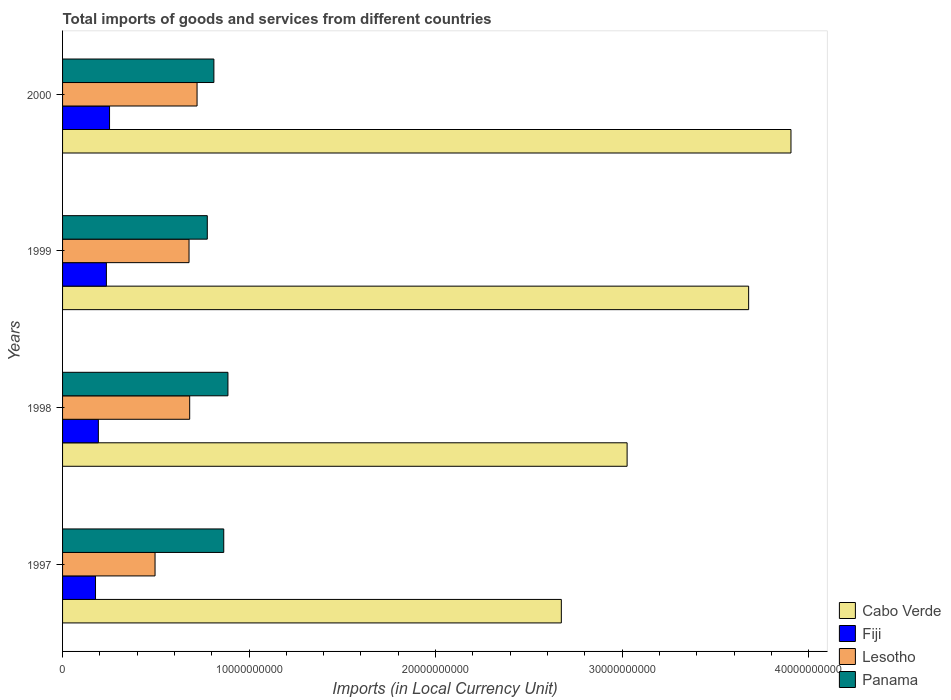How many different coloured bars are there?
Give a very brief answer. 4. Are the number of bars on each tick of the Y-axis equal?
Give a very brief answer. Yes. How many bars are there on the 1st tick from the top?
Make the answer very short. 4. How many bars are there on the 2nd tick from the bottom?
Ensure brevity in your answer.  4. What is the label of the 1st group of bars from the top?
Your answer should be very brief. 2000. What is the Amount of goods and services imports in Cabo Verde in 2000?
Provide a short and direct response. 3.91e+1. Across all years, what is the maximum Amount of goods and services imports in Cabo Verde?
Offer a terse response. 3.91e+1. Across all years, what is the minimum Amount of goods and services imports in Cabo Verde?
Offer a very short reply. 2.67e+1. In which year was the Amount of goods and services imports in Panama maximum?
Give a very brief answer. 1998. What is the total Amount of goods and services imports in Panama in the graph?
Your answer should be compact. 3.34e+1. What is the difference between the Amount of goods and services imports in Cabo Verde in 1998 and that in 1999?
Your answer should be compact. -6.52e+09. What is the difference between the Amount of goods and services imports in Fiji in 2000 and the Amount of goods and services imports in Cabo Verde in 1999?
Your answer should be compact. -3.43e+1. What is the average Amount of goods and services imports in Panama per year?
Provide a short and direct response. 8.35e+09. In the year 2000, what is the difference between the Amount of goods and services imports in Panama and Amount of goods and services imports in Lesotho?
Make the answer very short. 9.02e+08. In how many years, is the Amount of goods and services imports in Fiji greater than 20000000000 LCU?
Your answer should be very brief. 0. What is the ratio of the Amount of goods and services imports in Fiji in 1997 to that in 1998?
Keep it short and to the point. 0.92. Is the Amount of goods and services imports in Cabo Verde in 1997 less than that in 1998?
Your answer should be compact. Yes. What is the difference between the highest and the second highest Amount of goods and services imports in Panama?
Keep it short and to the point. 2.24e+08. What is the difference between the highest and the lowest Amount of goods and services imports in Fiji?
Make the answer very short. 7.52e+08. In how many years, is the Amount of goods and services imports in Panama greater than the average Amount of goods and services imports in Panama taken over all years?
Your answer should be very brief. 2. What does the 2nd bar from the top in 1998 represents?
Your answer should be compact. Lesotho. What does the 2nd bar from the bottom in 1999 represents?
Keep it short and to the point. Fiji. Is it the case that in every year, the sum of the Amount of goods and services imports in Lesotho and Amount of goods and services imports in Panama is greater than the Amount of goods and services imports in Cabo Verde?
Your response must be concise. No. What is the difference between two consecutive major ticks on the X-axis?
Keep it short and to the point. 1.00e+1. Are the values on the major ticks of X-axis written in scientific E-notation?
Offer a very short reply. No. Does the graph contain grids?
Ensure brevity in your answer.  No. Where does the legend appear in the graph?
Provide a short and direct response. Bottom right. What is the title of the graph?
Your answer should be compact. Total imports of goods and services from different countries. Does "Oman" appear as one of the legend labels in the graph?
Ensure brevity in your answer.  No. What is the label or title of the X-axis?
Your answer should be compact. Imports (in Local Currency Unit). What is the label or title of the Y-axis?
Provide a succinct answer. Years. What is the Imports (in Local Currency Unit) of Cabo Verde in 1997?
Make the answer very short. 2.67e+1. What is the Imports (in Local Currency Unit) in Fiji in 1997?
Provide a succinct answer. 1.77e+09. What is the Imports (in Local Currency Unit) of Lesotho in 1997?
Offer a very short reply. 4.96e+09. What is the Imports (in Local Currency Unit) in Panama in 1997?
Make the answer very short. 8.64e+09. What is the Imports (in Local Currency Unit) of Cabo Verde in 1998?
Keep it short and to the point. 3.03e+1. What is the Imports (in Local Currency Unit) in Fiji in 1998?
Provide a short and direct response. 1.92e+09. What is the Imports (in Local Currency Unit) in Lesotho in 1998?
Offer a terse response. 6.82e+09. What is the Imports (in Local Currency Unit) of Panama in 1998?
Offer a very short reply. 8.87e+09. What is the Imports (in Local Currency Unit) of Cabo Verde in 1999?
Make the answer very short. 3.68e+1. What is the Imports (in Local Currency Unit) of Fiji in 1999?
Your answer should be very brief. 2.35e+09. What is the Imports (in Local Currency Unit) in Lesotho in 1999?
Your answer should be very brief. 6.78e+09. What is the Imports (in Local Currency Unit) of Panama in 1999?
Your answer should be very brief. 7.76e+09. What is the Imports (in Local Currency Unit) of Cabo Verde in 2000?
Keep it short and to the point. 3.91e+1. What is the Imports (in Local Currency Unit) in Fiji in 2000?
Give a very brief answer. 2.52e+09. What is the Imports (in Local Currency Unit) of Lesotho in 2000?
Ensure brevity in your answer.  7.21e+09. What is the Imports (in Local Currency Unit) in Panama in 2000?
Provide a succinct answer. 8.11e+09. Across all years, what is the maximum Imports (in Local Currency Unit) in Cabo Verde?
Your response must be concise. 3.91e+1. Across all years, what is the maximum Imports (in Local Currency Unit) of Fiji?
Offer a terse response. 2.52e+09. Across all years, what is the maximum Imports (in Local Currency Unit) in Lesotho?
Make the answer very short. 7.21e+09. Across all years, what is the maximum Imports (in Local Currency Unit) of Panama?
Offer a very short reply. 8.87e+09. Across all years, what is the minimum Imports (in Local Currency Unit) in Cabo Verde?
Offer a terse response. 2.67e+1. Across all years, what is the minimum Imports (in Local Currency Unit) of Fiji?
Provide a succinct answer. 1.77e+09. Across all years, what is the minimum Imports (in Local Currency Unit) in Lesotho?
Make the answer very short. 4.96e+09. Across all years, what is the minimum Imports (in Local Currency Unit) of Panama?
Provide a short and direct response. 7.76e+09. What is the total Imports (in Local Currency Unit) in Cabo Verde in the graph?
Your response must be concise. 1.33e+11. What is the total Imports (in Local Currency Unit) of Fiji in the graph?
Ensure brevity in your answer.  8.55e+09. What is the total Imports (in Local Currency Unit) in Lesotho in the graph?
Give a very brief answer. 2.58e+1. What is the total Imports (in Local Currency Unit) in Panama in the graph?
Your response must be concise. 3.34e+1. What is the difference between the Imports (in Local Currency Unit) in Cabo Verde in 1997 and that in 1998?
Provide a succinct answer. -3.53e+09. What is the difference between the Imports (in Local Currency Unit) of Fiji in 1997 and that in 1998?
Your response must be concise. -1.52e+08. What is the difference between the Imports (in Local Currency Unit) in Lesotho in 1997 and that in 1998?
Give a very brief answer. -1.86e+09. What is the difference between the Imports (in Local Currency Unit) of Panama in 1997 and that in 1998?
Provide a short and direct response. -2.24e+08. What is the difference between the Imports (in Local Currency Unit) in Cabo Verde in 1997 and that in 1999?
Offer a terse response. -1.00e+1. What is the difference between the Imports (in Local Currency Unit) of Fiji in 1997 and that in 1999?
Keep it short and to the point. -5.83e+08. What is the difference between the Imports (in Local Currency Unit) in Lesotho in 1997 and that in 1999?
Offer a terse response. -1.82e+09. What is the difference between the Imports (in Local Currency Unit) of Panama in 1997 and that in 1999?
Offer a terse response. 8.82e+08. What is the difference between the Imports (in Local Currency Unit) in Cabo Verde in 1997 and that in 2000?
Ensure brevity in your answer.  -1.23e+1. What is the difference between the Imports (in Local Currency Unit) of Fiji in 1997 and that in 2000?
Make the answer very short. -7.52e+08. What is the difference between the Imports (in Local Currency Unit) in Lesotho in 1997 and that in 2000?
Offer a very short reply. -2.25e+09. What is the difference between the Imports (in Local Currency Unit) of Panama in 1997 and that in 2000?
Keep it short and to the point. 5.29e+08. What is the difference between the Imports (in Local Currency Unit) in Cabo Verde in 1998 and that in 1999?
Offer a terse response. -6.52e+09. What is the difference between the Imports (in Local Currency Unit) of Fiji in 1998 and that in 1999?
Make the answer very short. -4.30e+08. What is the difference between the Imports (in Local Currency Unit) in Lesotho in 1998 and that in 1999?
Offer a very short reply. 3.50e+07. What is the difference between the Imports (in Local Currency Unit) in Panama in 1998 and that in 1999?
Ensure brevity in your answer.  1.11e+09. What is the difference between the Imports (in Local Currency Unit) in Cabo Verde in 1998 and that in 2000?
Offer a terse response. -8.79e+09. What is the difference between the Imports (in Local Currency Unit) of Fiji in 1998 and that in 2000?
Ensure brevity in your answer.  -6.00e+08. What is the difference between the Imports (in Local Currency Unit) of Lesotho in 1998 and that in 2000?
Your answer should be very brief. -3.95e+08. What is the difference between the Imports (in Local Currency Unit) in Panama in 1998 and that in 2000?
Ensure brevity in your answer.  7.54e+08. What is the difference between the Imports (in Local Currency Unit) in Cabo Verde in 1999 and that in 2000?
Your response must be concise. -2.27e+09. What is the difference between the Imports (in Local Currency Unit) of Fiji in 1999 and that in 2000?
Make the answer very short. -1.69e+08. What is the difference between the Imports (in Local Currency Unit) of Lesotho in 1999 and that in 2000?
Give a very brief answer. -4.30e+08. What is the difference between the Imports (in Local Currency Unit) of Panama in 1999 and that in 2000?
Your answer should be compact. -3.53e+08. What is the difference between the Imports (in Local Currency Unit) of Cabo Verde in 1997 and the Imports (in Local Currency Unit) of Fiji in 1998?
Keep it short and to the point. 2.48e+1. What is the difference between the Imports (in Local Currency Unit) of Cabo Verde in 1997 and the Imports (in Local Currency Unit) of Lesotho in 1998?
Ensure brevity in your answer.  1.99e+1. What is the difference between the Imports (in Local Currency Unit) of Cabo Verde in 1997 and the Imports (in Local Currency Unit) of Panama in 1998?
Provide a succinct answer. 1.79e+1. What is the difference between the Imports (in Local Currency Unit) in Fiji in 1997 and the Imports (in Local Currency Unit) in Lesotho in 1998?
Your response must be concise. -5.05e+09. What is the difference between the Imports (in Local Currency Unit) in Fiji in 1997 and the Imports (in Local Currency Unit) in Panama in 1998?
Offer a terse response. -7.10e+09. What is the difference between the Imports (in Local Currency Unit) of Lesotho in 1997 and the Imports (in Local Currency Unit) of Panama in 1998?
Keep it short and to the point. -3.91e+09. What is the difference between the Imports (in Local Currency Unit) of Cabo Verde in 1997 and the Imports (in Local Currency Unit) of Fiji in 1999?
Ensure brevity in your answer.  2.44e+1. What is the difference between the Imports (in Local Currency Unit) in Cabo Verde in 1997 and the Imports (in Local Currency Unit) in Lesotho in 1999?
Offer a terse response. 2.00e+1. What is the difference between the Imports (in Local Currency Unit) in Cabo Verde in 1997 and the Imports (in Local Currency Unit) in Panama in 1999?
Make the answer very short. 1.90e+1. What is the difference between the Imports (in Local Currency Unit) in Fiji in 1997 and the Imports (in Local Currency Unit) in Lesotho in 1999?
Your answer should be compact. -5.01e+09. What is the difference between the Imports (in Local Currency Unit) in Fiji in 1997 and the Imports (in Local Currency Unit) in Panama in 1999?
Ensure brevity in your answer.  -5.99e+09. What is the difference between the Imports (in Local Currency Unit) of Lesotho in 1997 and the Imports (in Local Currency Unit) of Panama in 1999?
Your answer should be very brief. -2.80e+09. What is the difference between the Imports (in Local Currency Unit) of Cabo Verde in 1997 and the Imports (in Local Currency Unit) of Fiji in 2000?
Provide a succinct answer. 2.42e+1. What is the difference between the Imports (in Local Currency Unit) in Cabo Verde in 1997 and the Imports (in Local Currency Unit) in Lesotho in 2000?
Make the answer very short. 1.95e+1. What is the difference between the Imports (in Local Currency Unit) in Cabo Verde in 1997 and the Imports (in Local Currency Unit) in Panama in 2000?
Keep it short and to the point. 1.86e+1. What is the difference between the Imports (in Local Currency Unit) of Fiji in 1997 and the Imports (in Local Currency Unit) of Lesotho in 2000?
Keep it short and to the point. -5.44e+09. What is the difference between the Imports (in Local Currency Unit) in Fiji in 1997 and the Imports (in Local Currency Unit) in Panama in 2000?
Provide a short and direct response. -6.35e+09. What is the difference between the Imports (in Local Currency Unit) in Lesotho in 1997 and the Imports (in Local Currency Unit) in Panama in 2000?
Your answer should be compact. -3.15e+09. What is the difference between the Imports (in Local Currency Unit) in Cabo Verde in 1998 and the Imports (in Local Currency Unit) in Fiji in 1999?
Your answer should be compact. 2.79e+1. What is the difference between the Imports (in Local Currency Unit) in Cabo Verde in 1998 and the Imports (in Local Currency Unit) in Lesotho in 1999?
Your answer should be very brief. 2.35e+1. What is the difference between the Imports (in Local Currency Unit) in Cabo Verde in 1998 and the Imports (in Local Currency Unit) in Panama in 1999?
Your answer should be compact. 2.25e+1. What is the difference between the Imports (in Local Currency Unit) in Fiji in 1998 and the Imports (in Local Currency Unit) in Lesotho in 1999?
Provide a short and direct response. -4.86e+09. What is the difference between the Imports (in Local Currency Unit) in Fiji in 1998 and the Imports (in Local Currency Unit) in Panama in 1999?
Provide a succinct answer. -5.84e+09. What is the difference between the Imports (in Local Currency Unit) of Lesotho in 1998 and the Imports (in Local Currency Unit) of Panama in 1999?
Ensure brevity in your answer.  -9.44e+08. What is the difference between the Imports (in Local Currency Unit) of Cabo Verde in 1998 and the Imports (in Local Currency Unit) of Fiji in 2000?
Your answer should be compact. 2.78e+1. What is the difference between the Imports (in Local Currency Unit) in Cabo Verde in 1998 and the Imports (in Local Currency Unit) in Lesotho in 2000?
Keep it short and to the point. 2.31e+1. What is the difference between the Imports (in Local Currency Unit) in Cabo Verde in 1998 and the Imports (in Local Currency Unit) in Panama in 2000?
Make the answer very short. 2.22e+1. What is the difference between the Imports (in Local Currency Unit) in Fiji in 1998 and the Imports (in Local Currency Unit) in Lesotho in 2000?
Make the answer very short. -5.29e+09. What is the difference between the Imports (in Local Currency Unit) in Fiji in 1998 and the Imports (in Local Currency Unit) in Panama in 2000?
Provide a succinct answer. -6.19e+09. What is the difference between the Imports (in Local Currency Unit) in Lesotho in 1998 and the Imports (in Local Currency Unit) in Panama in 2000?
Ensure brevity in your answer.  -1.30e+09. What is the difference between the Imports (in Local Currency Unit) in Cabo Verde in 1999 and the Imports (in Local Currency Unit) in Fiji in 2000?
Your answer should be very brief. 3.43e+1. What is the difference between the Imports (in Local Currency Unit) of Cabo Verde in 1999 and the Imports (in Local Currency Unit) of Lesotho in 2000?
Make the answer very short. 2.96e+1. What is the difference between the Imports (in Local Currency Unit) in Cabo Verde in 1999 and the Imports (in Local Currency Unit) in Panama in 2000?
Ensure brevity in your answer.  2.87e+1. What is the difference between the Imports (in Local Currency Unit) of Fiji in 1999 and the Imports (in Local Currency Unit) of Lesotho in 2000?
Ensure brevity in your answer.  -4.86e+09. What is the difference between the Imports (in Local Currency Unit) in Fiji in 1999 and the Imports (in Local Currency Unit) in Panama in 2000?
Provide a short and direct response. -5.76e+09. What is the difference between the Imports (in Local Currency Unit) of Lesotho in 1999 and the Imports (in Local Currency Unit) of Panama in 2000?
Provide a short and direct response. -1.33e+09. What is the average Imports (in Local Currency Unit) in Cabo Verde per year?
Your answer should be compact. 3.32e+1. What is the average Imports (in Local Currency Unit) of Fiji per year?
Make the answer very short. 2.14e+09. What is the average Imports (in Local Currency Unit) of Lesotho per year?
Your answer should be compact. 6.44e+09. What is the average Imports (in Local Currency Unit) of Panama per year?
Provide a short and direct response. 8.35e+09. In the year 1997, what is the difference between the Imports (in Local Currency Unit) in Cabo Verde and Imports (in Local Currency Unit) in Fiji?
Keep it short and to the point. 2.50e+1. In the year 1997, what is the difference between the Imports (in Local Currency Unit) of Cabo Verde and Imports (in Local Currency Unit) of Lesotho?
Offer a terse response. 2.18e+1. In the year 1997, what is the difference between the Imports (in Local Currency Unit) of Cabo Verde and Imports (in Local Currency Unit) of Panama?
Make the answer very short. 1.81e+1. In the year 1997, what is the difference between the Imports (in Local Currency Unit) of Fiji and Imports (in Local Currency Unit) of Lesotho?
Offer a terse response. -3.19e+09. In the year 1997, what is the difference between the Imports (in Local Currency Unit) of Fiji and Imports (in Local Currency Unit) of Panama?
Your answer should be very brief. -6.88e+09. In the year 1997, what is the difference between the Imports (in Local Currency Unit) in Lesotho and Imports (in Local Currency Unit) in Panama?
Make the answer very short. -3.68e+09. In the year 1998, what is the difference between the Imports (in Local Currency Unit) in Cabo Verde and Imports (in Local Currency Unit) in Fiji?
Your answer should be compact. 2.84e+1. In the year 1998, what is the difference between the Imports (in Local Currency Unit) in Cabo Verde and Imports (in Local Currency Unit) in Lesotho?
Provide a succinct answer. 2.35e+1. In the year 1998, what is the difference between the Imports (in Local Currency Unit) of Cabo Verde and Imports (in Local Currency Unit) of Panama?
Give a very brief answer. 2.14e+1. In the year 1998, what is the difference between the Imports (in Local Currency Unit) of Fiji and Imports (in Local Currency Unit) of Lesotho?
Your response must be concise. -4.90e+09. In the year 1998, what is the difference between the Imports (in Local Currency Unit) of Fiji and Imports (in Local Currency Unit) of Panama?
Your answer should be compact. -6.95e+09. In the year 1998, what is the difference between the Imports (in Local Currency Unit) in Lesotho and Imports (in Local Currency Unit) in Panama?
Offer a terse response. -2.05e+09. In the year 1999, what is the difference between the Imports (in Local Currency Unit) of Cabo Verde and Imports (in Local Currency Unit) of Fiji?
Your answer should be compact. 3.44e+1. In the year 1999, what is the difference between the Imports (in Local Currency Unit) in Cabo Verde and Imports (in Local Currency Unit) in Lesotho?
Keep it short and to the point. 3.00e+1. In the year 1999, what is the difference between the Imports (in Local Currency Unit) in Cabo Verde and Imports (in Local Currency Unit) in Panama?
Offer a terse response. 2.90e+1. In the year 1999, what is the difference between the Imports (in Local Currency Unit) of Fiji and Imports (in Local Currency Unit) of Lesotho?
Give a very brief answer. -4.43e+09. In the year 1999, what is the difference between the Imports (in Local Currency Unit) in Fiji and Imports (in Local Currency Unit) in Panama?
Give a very brief answer. -5.41e+09. In the year 1999, what is the difference between the Imports (in Local Currency Unit) of Lesotho and Imports (in Local Currency Unit) of Panama?
Your answer should be compact. -9.79e+08. In the year 2000, what is the difference between the Imports (in Local Currency Unit) in Cabo Verde and Imports (in Local Currency Unit) in Fiji?
Provide a short and direct response. 3.65e+1. In the year 2000, what is the difference between the Imports (in Local Currency Unit) of Cabo Verde and Imports (in Local Currency Unit) of Lesotho?
Your answer should be very brief. 3.18e+1. In the year 2000, what is the difference between the Imports (in Local Currency Unit) in Cabo Verde and Imports (in Local Currency Unit) in Panama?
Make the answer very short. 3.09e+1. In the year 2000, what is the difference between the Imports (in Local Currency Unit) in Fiji and Imports (in Local Currency Unit) in Lesotho?
Offer a terse response. -4.69e+09. In the year 2000, what is the difference between the Imports (in Local Currency Unit) in Fiji and Imports (in Local Currency Unit) in Panama?
Make the answer very short. -5.59e+09. In the year 2000, what is the difference between the Imports (in Local Currency Unit) of Lesotho and Imports (in Local Currency Unit) of Panama?
Your response must be concise. -9.02e+08. What is the ratio of the Imports (in Local Currency Unit) of Cabo Verde in 1997 to that in 1998?
Offer a very short reply. 0.88. What is the ratio of the Imports (in Local Currency Unit) of Fiji in 1997 to that in 1998?
Your answer should be compact. 0.92. What is the ratio of the Imports (in Local Currency Unit) in Lesotho in 1997 to that in 1998?
Offer a very short reply. 0.73. What is the ratio of the Imports (in Local Currency Unit) in Panama in 1997 to that in 1998?
Give a very brief answer. 0.97. What is the ratio of the Imports (in Local Currency Unit) of Cabo Verde in 1997 to that in 1999?
Offer a terse response. 0.73. What is the ratio of the Imports (in Local Currency Unit) of Fiji in 1997 to that in 1999?
Provide a short and direct response. 0.75. What is the ratio of the Imports (in Local Currency Unit) in Lesotho in 1997 to that in 1999?
Your answer should be very brief. 0.73. What is the ratio of the Imports (in Local Currency Unit) in Panama in 1997 to that in 1999?
Your response must be concise. 1.11. What is the ratio of the Imports (in Local Currency Unit) in Cabo Verde in 1997 to that in 2000?
Your answer should be very brief. 0.68. What is the ratio of the Imports (in Local Currency Unit) of Fiji in 1997 to that in 2000?
Your answer should be very brief. 0.7. What is the ratio of the Imports (in Local Currency Unit) in Lesotho in 1997 to that in 2000?
Your answer should be compact. 0.69. What is the ratio of the Imports (in Local Currency Unit) of Panama in 1997 to that in 2000?
Provide a short and direct response. 1.07. What is the ratio of the Imports (in Local Currency Unit) of Cabo Verde in 1998 to that in 1999?
Make the answer very short. 0.82. What is the ratio of the Imports (in Local Currency Unit) in Fiji in 1998 to that in 1999?
Your answer should be compact. 0.82. What is the ratio of the Imports (in Local Currency Unit) of Lesotho in 1998 to that in 1999?
Give a very brief answer. 1.01. What is the ratio of the Imports (in Local Currency Unit) of Panama in 1998 to that in 1999?
Your response must be concise. 1.14. What is the ratio of the Imports (in Local Currency Unit) of Cabo Verde in 1998 to that in 2000?
Your response must be concise. 0.78. What is the ratio of the Imports (in Local Currency Unit) in Fiji in 1998 to that in 2000?
Your answer should be compact. 0.76. What is the ratio of the Imports (in Local Currency Unit) in Lesotho in 1998 to that in 2000?
Make the answer very short. 0.95. What is the ratio of the Imports (in Local Currency Unit) of Panama in 1998 to that in 2000?
Offer a very short reply. 1.09. What is the ratio of the Imports (in Local Currency Unit) in Cabo Verde in 1999 to that in 2000?
Provide a short and direct response. 0.94. What is the ratio of the Imports (in Local Currency Unit) in Fiji in 1999 to that in 2000?
Your response must be concise. 0.93. What is the ratio of the Imports (in Local Currency Unit) of Lesotho in 1999 to that in 2000?
Your answer should be very brief. 0.94. What is the ratio of the Imports (in Local Currency Unit) in Panama in 1999 to that in 2000?
Offer a very short reply. 0.96. What is the difference between the highest and the second highest Imports (in Local Currency Unit) of Cabo Verde?
Make the answer very short. 2.27e+09. What is the difference between the highest and the second highest Imports (in Local Currency Unit) of Fiji?
Your answer should be compact. 1.69e+08. What is the difference between the highest and the second highest Imports (in Local Currency Unit) in Lesotho?
Make the answer very short. 3.95e+08. What is the difference between the highest and the second highest Imports (in Local Currency Unit) in Panama?
Provide a short and direct response. 2.24e+08. What is the difference between the highest and the lowest Imports (in Local Currency Unit) in Cabo Verde?
Offer a terse response. 1.23e+1. What is the difference between the highest and the lowest Imports (in Local Currency Unit) of Fiji?
Your response must be concise. 7.52e+08. What is the difference between the highest and the lowest Imports (in Local Currency Unit) in Lesotho?
Provide a succinct answer. 2.25e+09. What is the difference between the highest and the lowest Imports (in Local Currency Unit) of Panama?
Offer a terse response. 1.11e+09. 